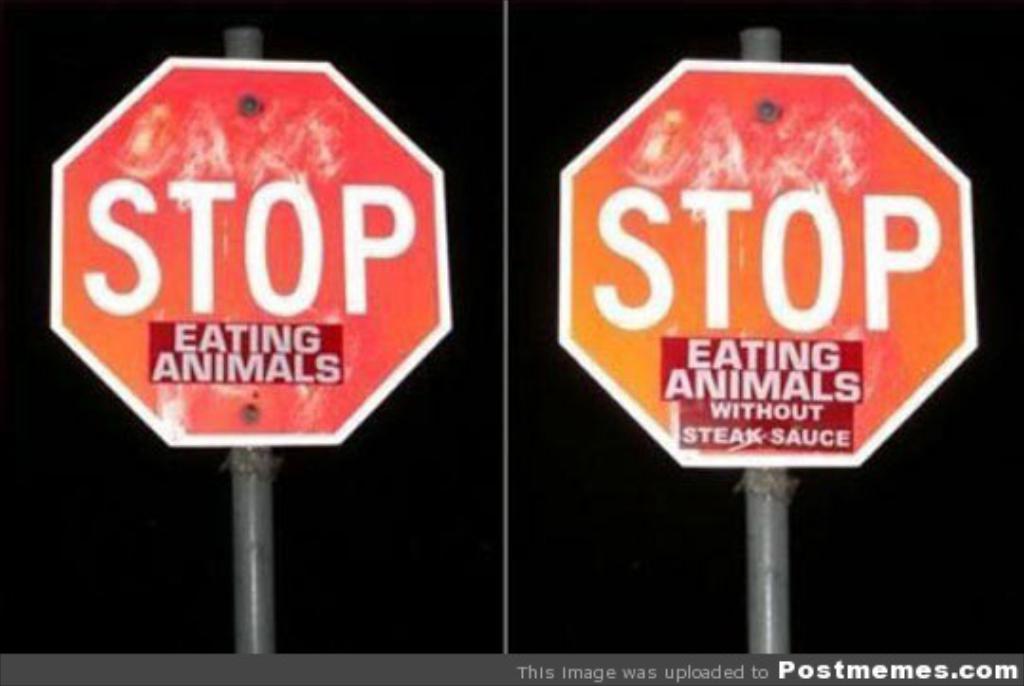Please provide a concise description of this image. In the image there are two pole with sign boards. There is something written on the boards. At the bottom of the image there is a name and website address. And there is a black background. 